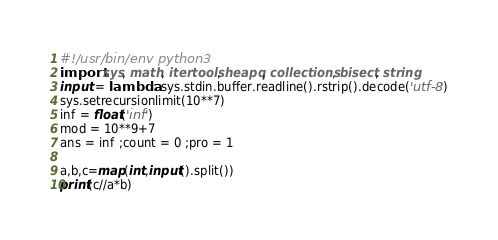Convert code to text. <code><loc_0><loc_0><loc_500><loc_500><_Python_>#!/usr/bin/env python3
import sys, math, itertools, heapq, collections, bisect, string
input = lambda: sys.stdin.buffer.readline().rstrip().decode('utf-8')
sys.setrecursionlimit(10**7)
inf = float('inf')
mod = 10**9+7
ans = inf ;count = 0 ;pro = 1

a,b,c=map(int,input().split())
print(c//a*b)</code> 